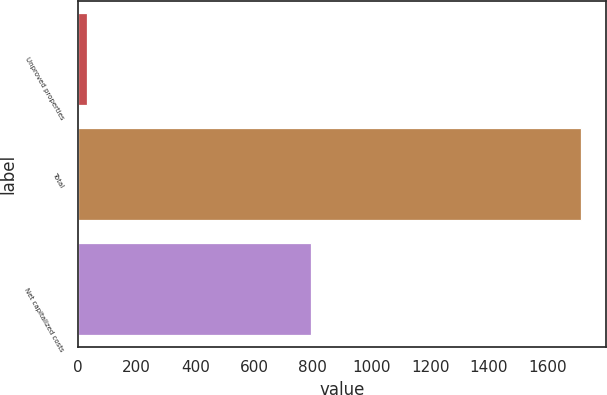Convert chart. <chart><loc_0><loc_0><loc_500><loc_500><bar_chart><fcel>Unproved properties<fcel>Total<fcel>Net capitalized costs<nl><fcel>31<fcel>1714<fcel>796<nl></chart> 